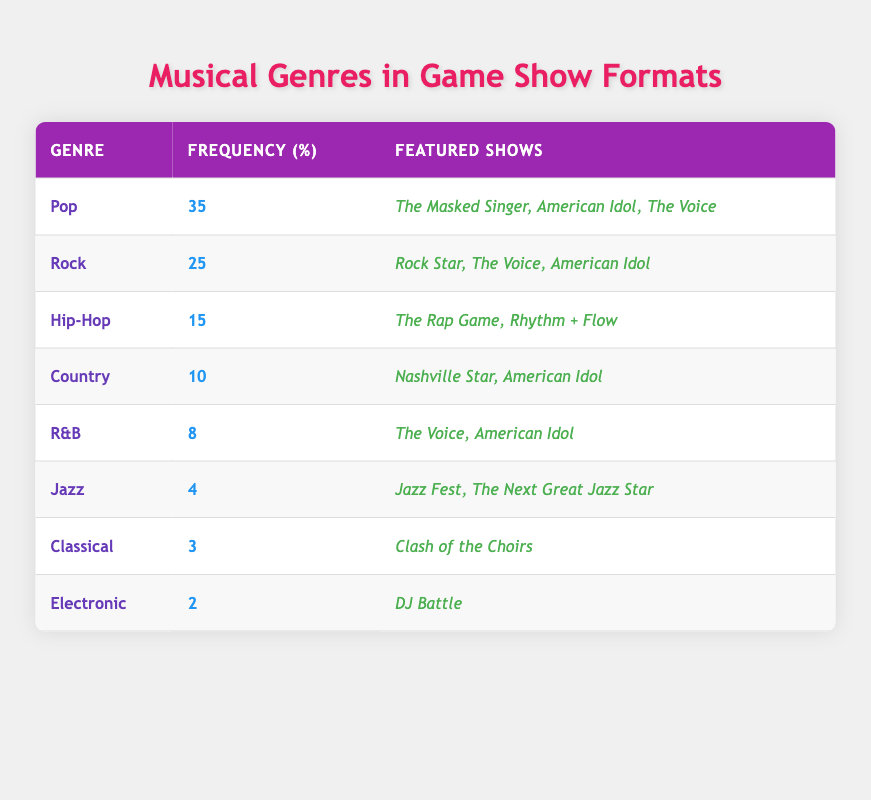What is the most frequently featured musical genre? The table lists musical genres along with their frequencies. The highest frequency is 35, which corresponds to the Pop genre.
Answer: Pop How many shows feature the Rock genre? The table shows that the Rock genre appears in three shows: Rock Star, The Voice, and American Idol.
Answer: 3 Is Jazz the least featured genre in the table? The Jazz genre has a frequency of 4, which is higher than Classical (3) and Electronic (2). Therefore, it is not the least featured genre.
Answer: No What is the total frequency of the Country and R&B genres combined? The frequency of Country is 10 and for R&B is 8. Adding these two gives 10 + 8 = 18.
Answer: 18 Which genres have been featured in more than two shows? By examining the table, Pop (3 shows) and Rock (3 shows) are the only genres listed with more than two shows.
Answer: Pop, Rock What is the average frequency of all musical genres listed in the table? The frequencies are 35, 25, 15, 10, 8, 4, 3, and 2. Summing these gives 35 + 25 + 15 + 10 + 8 + 4 + 3 + 2 = 102. There are 8 genres, so the average is 102/8 = 12.75.
Answer: 12.75 Are there any genres featured exclusively in more than one show? Reviewing the shows listed for each genre, Pop (3 shows), Rock (3 shows), Hip-Hop (2 shows), Country (2 shows), and R&B (2 shows) all feature in multiple shows.
Answer: Yes Which two genres have the same number of featured shows? The R&B genre (2 shows) has the same number of featured shows as the Electronic genre (1 show), and simultaneously, Hip-Hop (2 shows) matches with R&B.
Answer: R&B, Hip-Hop 